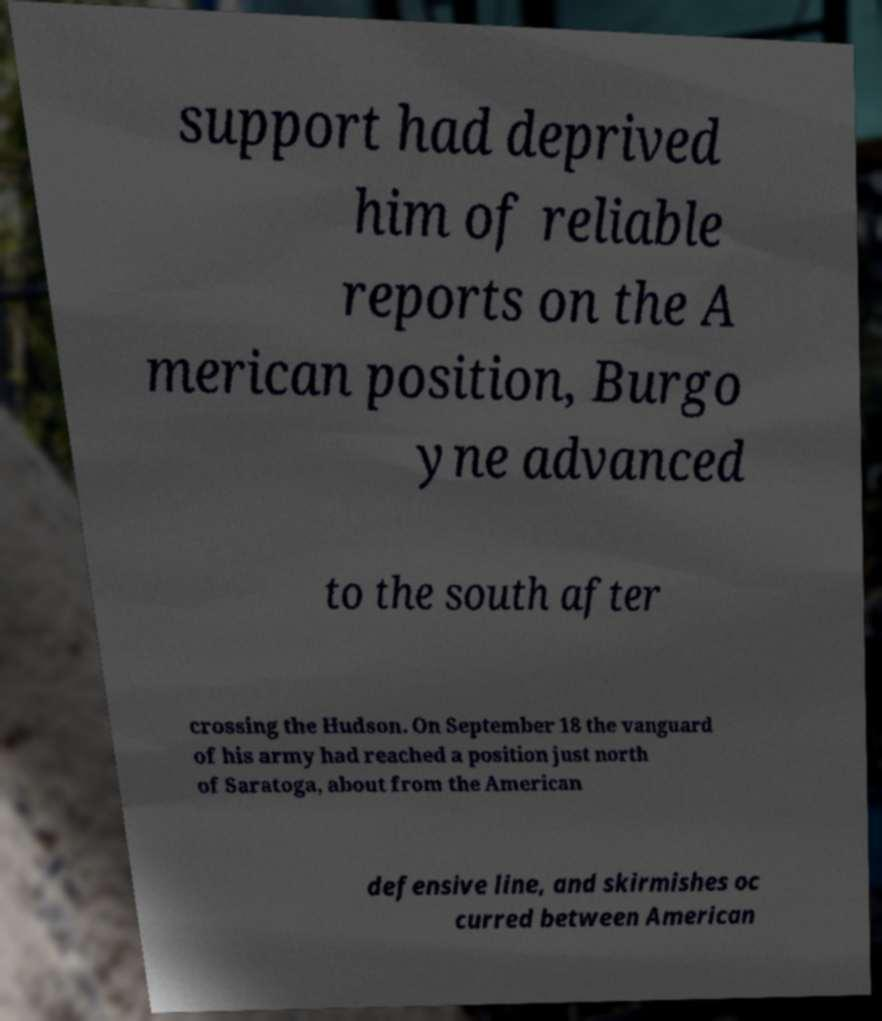I need the written content from this picture converted into text. Can you do that? support had deprived him of reliable reports on the A merican position, Burgo yne advanced to the south after crossing the Hudson. On September 18 the vanguard of his army had reached a position just north of Saratoga, about from the American defensive line, and skirmishes oc curred between American 